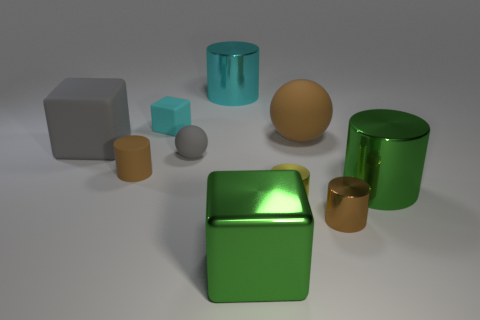Subtract all rubber cylinders. How many cylinders are left? 4 Subtract all cyan cubes. How many cubes are left? 2 Subtract all green balls. How many brown cylinders are left? 2 Subtract all cubes. How many objects are left? 7 Subtract 1 blocks. How many blocks are left? 2 Add 5 tiny brown objects. How many tiny brown objects are left? 7 Add 9 tiny purple matte blocks. How many tiny purple matte blocks exist? 9 Subtract 0 green balls. How many objects are left? 10 Subtract all cyan cylinders. Subtract all purple cubes. How many cylinders are left? 4 Subtract all large cyan blocks. Subtract all tiny brown matte things. How many objects are left? 9 